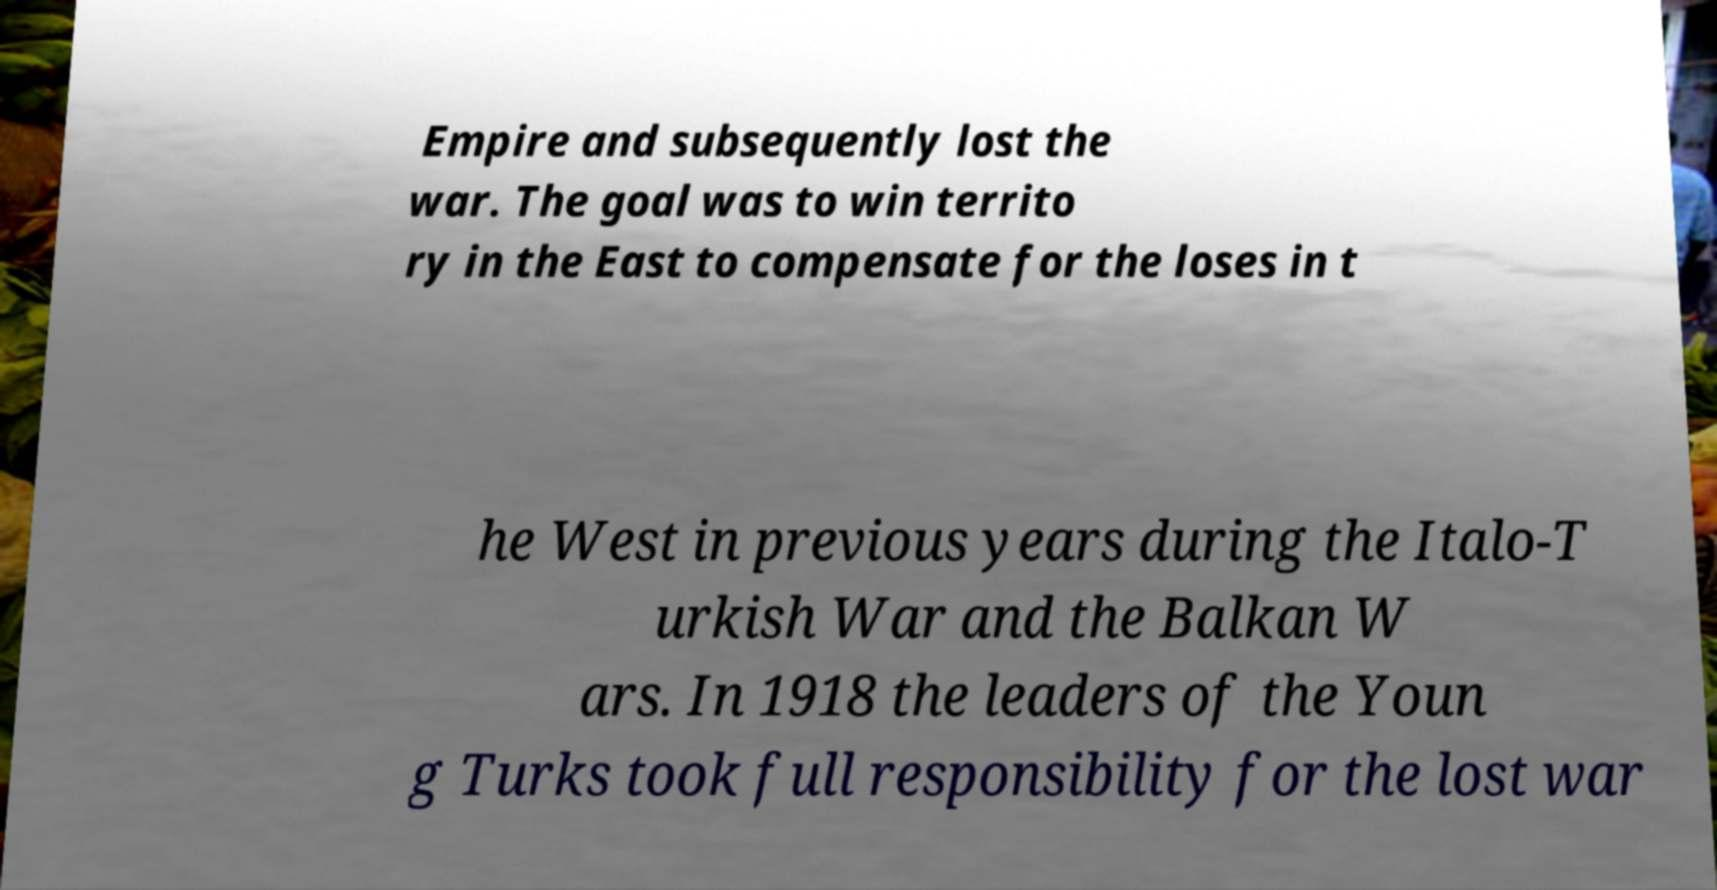What messages or text are displayed in this image? I need them in a readable, typed format. Empire and subsequently lost the war. The goal was to win territo ry in the East to compensate for the loses in t he West in previous years during the Italo-T urkish War and the Balkan W ars. In 1918 the leaders of the Youn g Turks took full responsibility for the lost war 